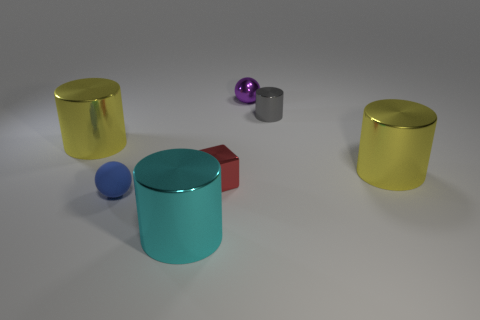Add 3 gray things. How many objects exist? 10 Subtract all balls. How many objects are left? 5 Subtract all tiny purple objects. Subtract all yellow cylinders. How many objects are left? 4 Add 3 gray cylinders. How many gray cylinders are left? 4 Add 6 purple shiny objects. How many purple shiny objects exist? 7 Subtract 0 green spheres. How many objects are left? 7 